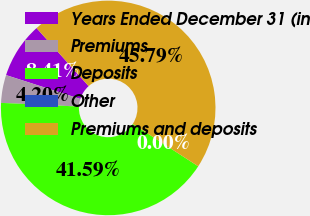Convert chart to OTSL. <chart><loc_0><loc_0><loc_500><loc_500><pie_chart><fcel>Years Ended December 31 (in<fcel>Premiums<fcel>Deposits<fcel>Other<fcel>Premiums and deposits<nl><fcel>8.41%<fcel>4.2%<fcel>41.59%<fcel>0.0%<fcel>45.79%<nl></chart> 